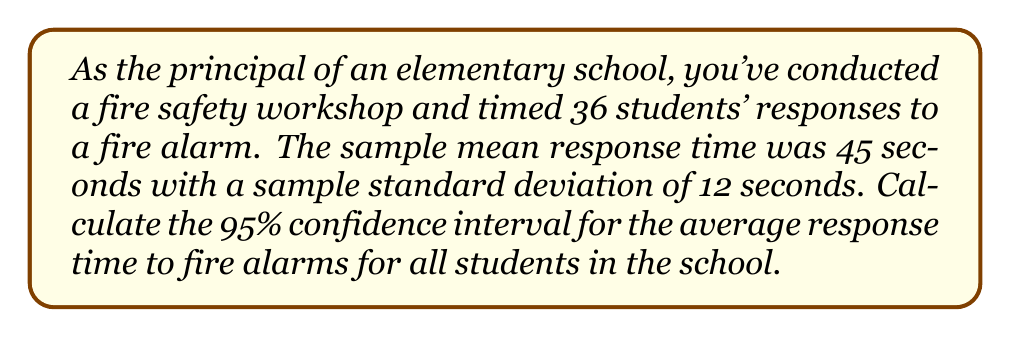Show me your answer to this math problem. To calculate the 95% confidence interval, we'll follow these steps:

1. Identify the known values:
   - Sample size (n) = 36
   - Sample mean (x̄) = 45 seconds
   - Sample standard deviation (s) = 12 seconds
   - Confidence level = 95% (α = 0.05)

2. Find the critical value (t-score) for a 95% confidence level with 35 degrees of freedom (df = n - 1 = 35):
   Using a t-distribution table or calculator, we find t₀.₀₂₅,₃₅ ≈ 2.030

3. Calculate the margin of error:
   Margin of Error = t * (s / √n)
   $$ \text{Margin of Error} = 2.030 \cdot \frac{12}{\sqrt{36}} = 2.030 \cdot 2 = 4.06 $$

4. Calculate the confidence interval:
   Lower bound = x̄ - Margin of Error
   Upper bound = x̄ + Margin of Error

   $$ \text{Lower bound} = 45 - 4.06 = 40.94 $$
   $$ \text{Upper bound} = 45 + 4.06 = 49.06 $$

5. Round the results to two decimal places:
   95% Confidence Interval: (40.94, 49.06)

This means we can be 95% confident that the true population mean response time for all students in the school falls between 40.94 and 49.06 seconds.
Answer: (40.94, 49.06) seconds 